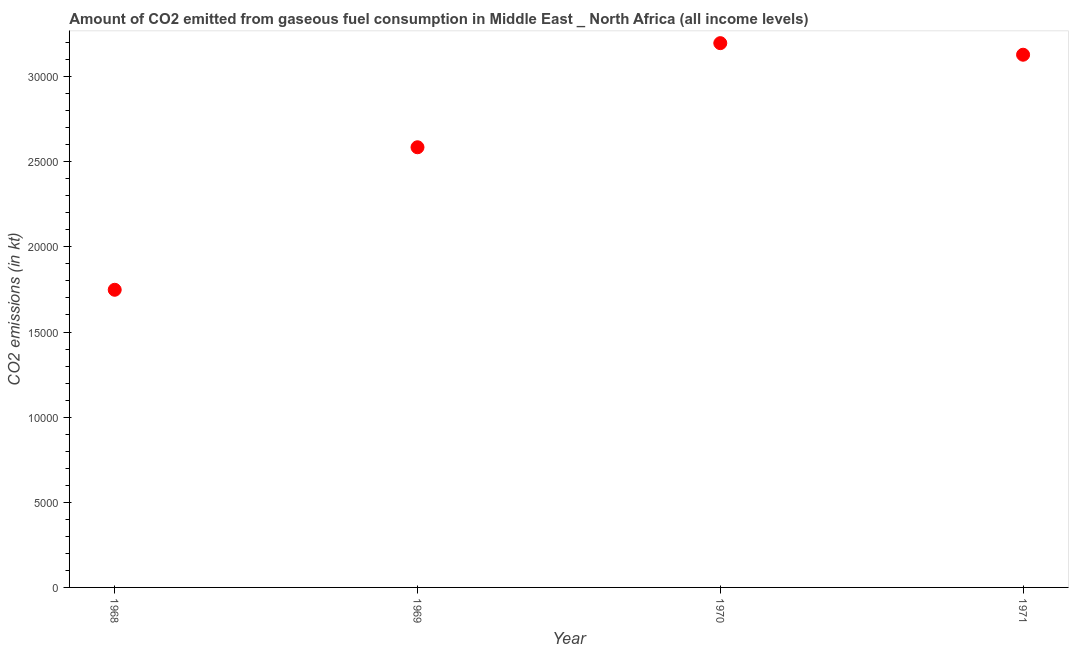What is the co2 emissions from gaseous fuel consumption in 1969?
Offer a very short reply. 2.59e+04. Across all years, what is the maximum co2 emissions from gaseous fuel consumption?
Make the answer very short. 3.20e+04. Across all years, what is the minimum co2 emissions from gaseous fuel consumption?
Ensure brevity in your answer.  1.75e+04. In which year was the co2 emissions from gaseous fuel consumption minimum?
Offer a terse response. 1968. What is the sum of the co2 emissions from gaseous fuel consumption?
Keep it short and to the point. 1.07e+05. What is the difference between the co2 emissions from gaseous fuel consumption in 1969 and 1970?
Your response must be concise. -6114.21. What is the average co2 emissions from gaseous fuel consumption per year?
Your answer should be compact. 2.66e+04. What is the median co2 emissions from gaseous fuel consumption?
Keep it short and to the point. 2.86e+04. Do a majority of the years between 1971 and 1969 (inclusive) have co2 emissions from gaseous fuel consumption greater than 30000 kt?
Offer a very short reply. No. What is the ratio of the co2 emissions from gaseous fuel consumption in 1969 to that in 1970?
Your answer should be compact. 0.81. Is the co2 emissions from gaseous fuel consumption in 1969 less than that in 1971?
Ensure brevity in your answer.  Yes. What is the difference between the highest and the second highest co2 emissions from gaseous fuel consumption?
Keep it short and to the point. 679.36. What is the difference between the highest and the lowest co2 emissions from gaseous fuel consumption?
Offer a terse response. 1.45e+04. In how many years, is the co2 emissions from gaseous fuel consumption greater than the average co2 emissions from gaseous fuel consumption taken over all years?
Offer a terse response. 2. Does the co2 emissions from gaseous fuel consumption monotonically increase over the years?
Your answer should be compact. No. How many dotlines are there?
Your response must be concise. 1. Are the values on the major ticks of Y-axis written in scientific E-notation?
Provide a short and direct response. No. What is the title of the graph?
Make the answer very short. Amount of CO2 emitted from gaseous fuel consumption in Middle East _ North Africa (all income levels). What is the label or title of the Y-axis?
Keep it short and to the point. CO2 emissions (in kt). What is the CO2 emissions (in kt) in 1968?
Your answer should be compact. 1.75e+04. What is the CO2 emissions (in kt) in 1969?
Your response must be concise. 2.59e+04. What is the CO2 emissions (in kt) in 1970?
Your answer should be very brief. 3.20e+04. What is the CO2 emissions (in kt) in 1971?
Provide a succinct answer. 3.13e+04. What is the difference between the CO2 emissions (in kt) in 1968 and 1969?
Your answer should be compact. -8369.81. What is the difference between the CO2 emissions (in kt) in 1968 and 1970?
Make the answer very short. -1.45e+04. What is the difference between the CO2 emissions (in kt) in 1968 and 1971?
Ensure brevity in your answer.  -1.38e+04. What is the difference between the CO2 emissions (in kt) in 1969 and 1970?
Ensure brevity in your answer.  -6114.21. What is the difference between the CO2 emissions (in kt) in 1969 and 1971?
Your answer should be very brief. -5434.86. What is the difference between the CO2 emissions (in kt) in 1970 and 1971?
Offer a terse response. 679.36. What is the ratio of the CO2 emissions (in kt) in 1968 to that in 1969?
Offer a terse response. 0.68. What is the ratio of the CO2 emissions (in kt) in 1968 to that in 1970?
Make the answer very short. 0.55. What is the ratio of the CO2 emissions (in kt) in 1968 to that in 1971?
Ensure brevity in your answer.  0.56. What is the ratio of the CO2 emissions (in kt) in 1969 to that in 1970?
Provide a succinct answer. 0.81. What is the ratio of the CO2 emissions (in kt) in 1969 to that in 1971?
Make the answer very short. 0.83. What is the ratio of the CO2 emissions (in kt) in 1970 to that in 1971?
Offer a very short reply. 1.02. 